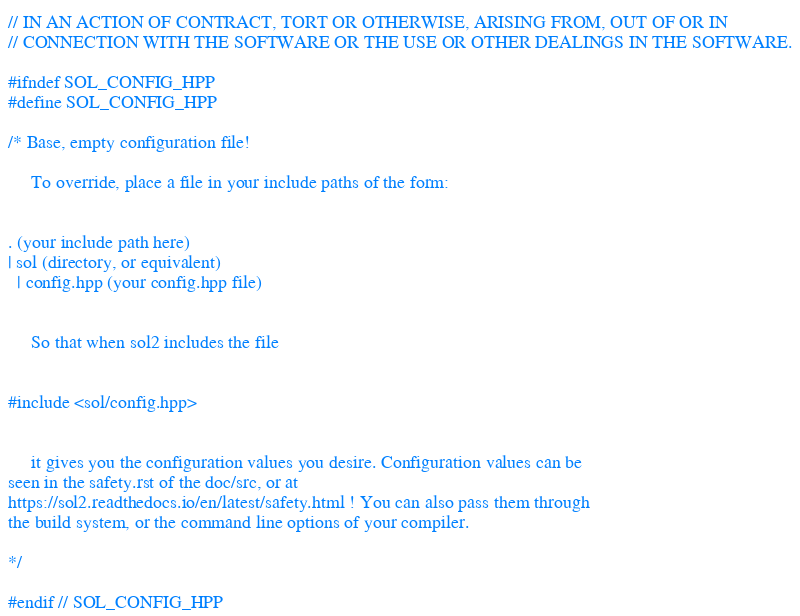<code> <loc_0><loc_0><loc_500><loc_500><_C++_>// IN AN ACTION OF CONTRACT, TORT OR OTHERWISE, ARISING FROM, OUT OF OR IN
// CONNECTION WITH THE SOFTWARE OR THE USE OR OTHER DEALINGS IN THE SOFTWARE.

#ifndef SOL_CONFIG_HPP
#define SOL_CONFIG_HPP

/* Base, empty configuration file!

     To override, place a file in your include paths of the form:


. (your include path here)
| sol (directory, or equivalent)
  | config.hpp (your config.hpp file)


     So that when sol2 includes the file


#include <sol/config.hpp>


     it gives you the configuration values you desire. Configuration values can be
seen in the safety.rst of the doc/src, or at
https://sol2.readthedocs.io/en/latest/safety.html ! You can also pass them through
the build system, or the command line options of your compiler.

*/

#endif // SOL_CONFIG_HPP
</code> 